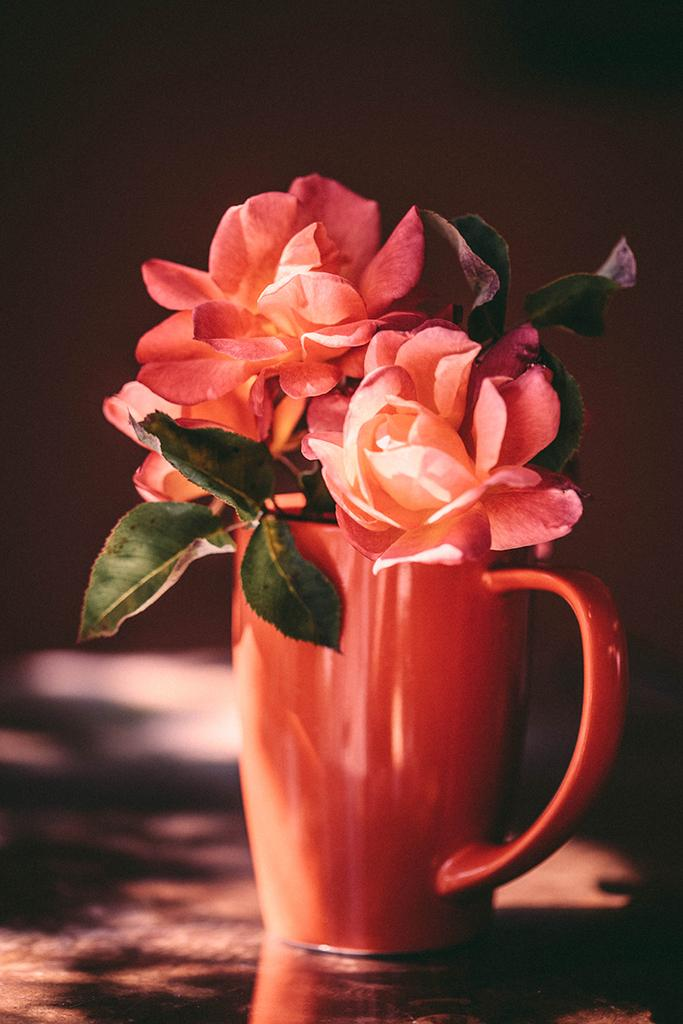What is inside the cup that is visible in the image? There are flowers and leaves in the cup that is visible in the image. Where is the cup located in the image? The cup is on a surface in the image. What can be observed about the background of the image? The background of the image is dark. What type of tent is visible in the image? There is no tent present in the image; it features a cup with flowers and leaves on a surface with a dark background. 